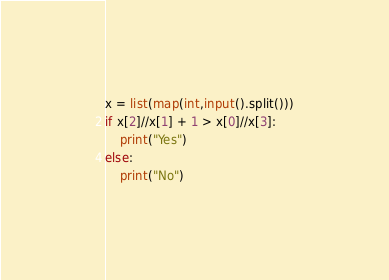Convert code to text. <code><loc_0><loc_0><loc_500><loc_500><_Python_>x = list(map(int,input().split()))
if x[2]//x[1] + 1 > x[0]//x[3]:
    print("Yes")
else:
    print("No")
</code> 